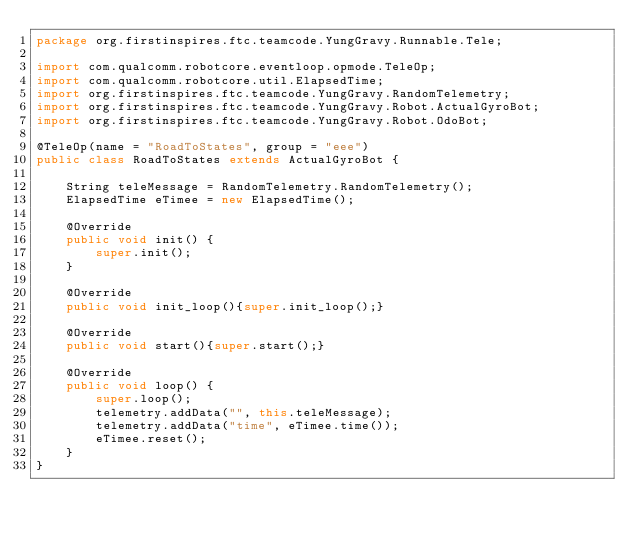Convert code to text. <code><loc_0><loc_0><loc_500><loc_500><_Java_>package org.firstinspires.ftc.teamcode.YungGravy.Runnable.Tele;

import com.qualcomm.robotcore.eventloop.opmode.TeleOp;
import com.qualcomm.robotcore.util.ElapsedTime;
import org.firstinspires.ftc.teamcode.YungGravy.RandomTelemetry;
import org.firstinspires.ftc.teamcode.YungGravy.Robot.ActualGyroBot;
import org.firstinspires.ftc.teamcode.YungGravy.Robot.OdoBot;

@TeleOp(name = "RoadToStates", group = "eee")
public class RoadToStates extends ActualGyroBot {

    String teleMessage = RandomTelemetry.RandomTelemetry();
    ElapsedTime eTimee = new ElapsedTime();

    @Override
    public void init() {
        super.init();
    }

    @Override
    public void init_loop(){super.init_loop();}

    @Override
    public void start(){super.start();}

    @Override
    public void loop() {
        super.loop();
        telemetry.addData("", this.teleMessage);
        telemetry.addData("time", eTimee.time());
        eTimee.reset();
    }
}</code> 